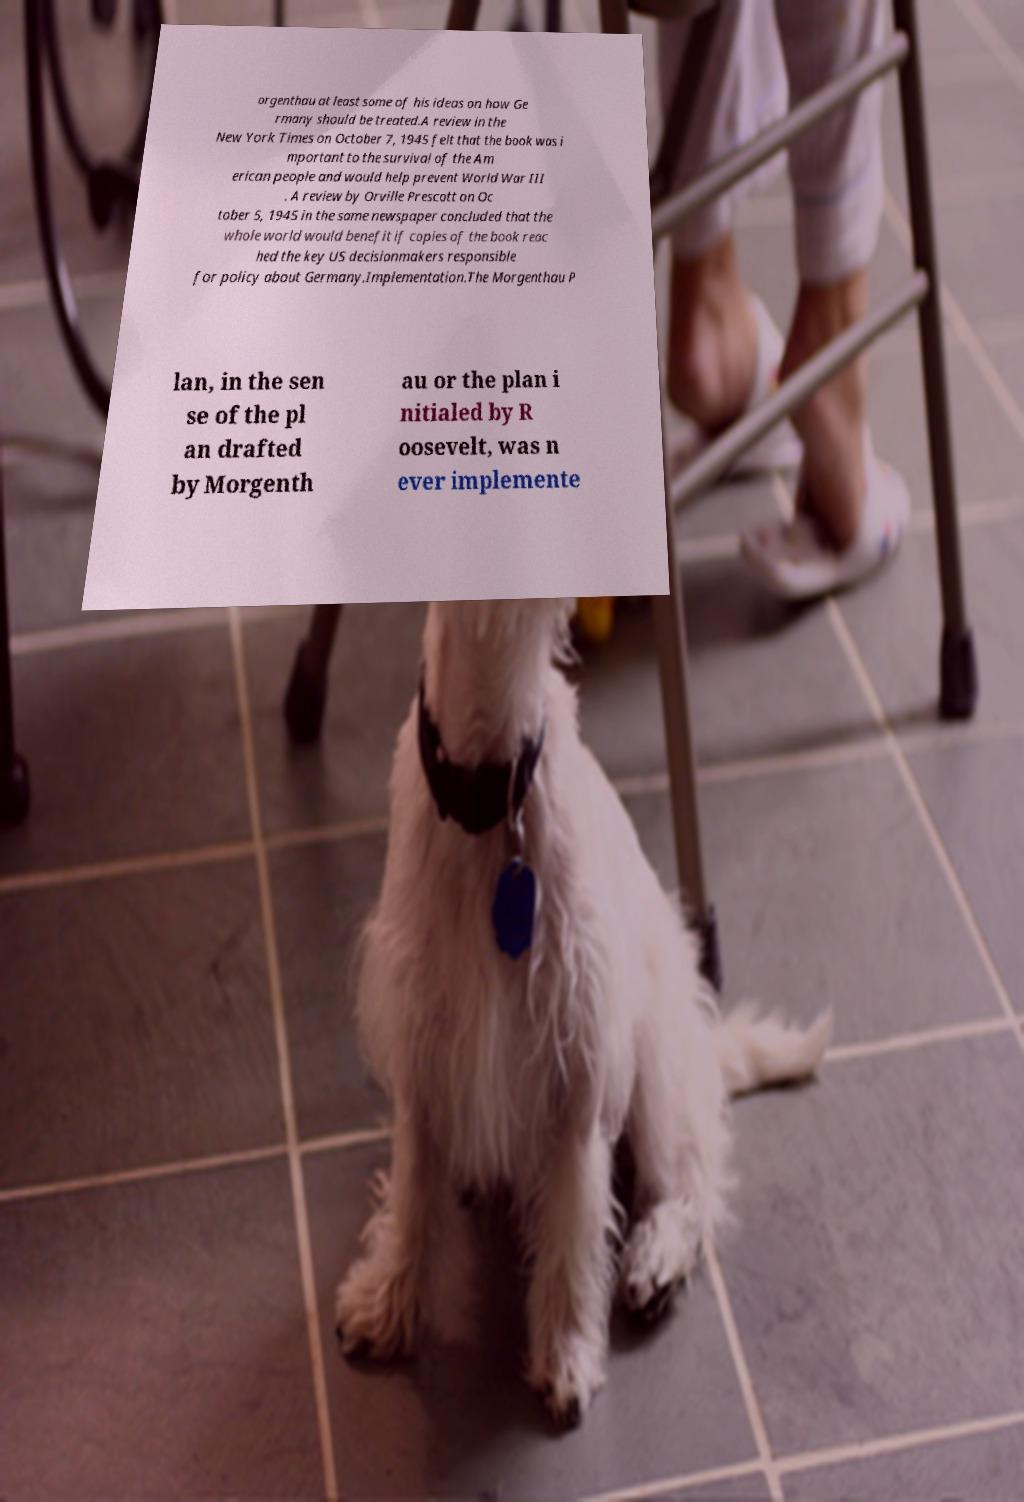Can you read and provide the text displayed in the image?This photo seems to have some interesting text. Can you extract and type it out for me? orgenthau at least some of his ideas on how Ge rmany should be treated.A review in the New York Times on October 7, 1945 felt that the book was i mportant to the survival of the Am erican people and would help prevent World War III . A review by Orville Prescott on Oc tober 5, 1945 in the same newspaper concluded that the whole world would benefit if copies of the book reac hed the key US decisionmakers responsible for policy about Germany.Implementation.The Morgenthau P lan, in the sen se of the pl an drafted by Morgenth au or the plan i nitialed by R oosevelt, was n ever implemente 